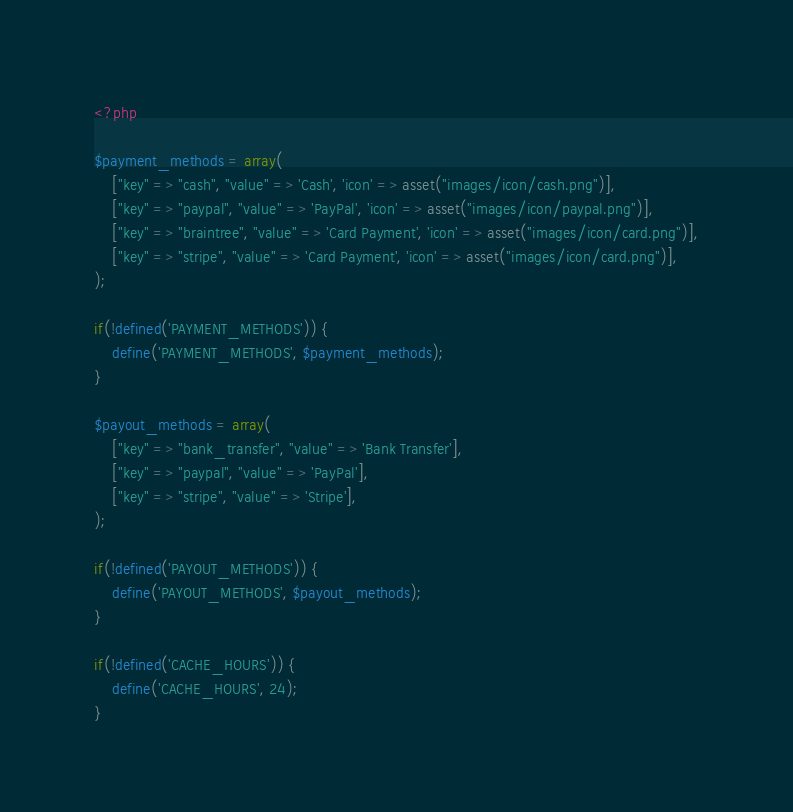<code> <loc_0><loc_0><loc_500><loc_500><_PHP_><?php

$payment_methods = array(
	["key" => "cash", "value" => 'Cash', 'icon' => asset("images/icon/cash.png")],
	["key" => "paypal", "value" => 'PayPal', 'icon' => asset("images/icon/paypal.png")],
	["key" => "braintree", "value" => 'Card Payment', 'icon' => asset("images/icon/card.png")],
	["key" => "stripe", "value" => 'Card Payment', 'icon' => asset("images/icon/card.png")],
);

if(!defined('PAYMENT_METHODS')) {
	define('PAYMENT_METHODS', $payment_methods);	
}

$payout_methods = array(
	["key" => "bank_transfer", "value" => 'Bank Transfer'],
	["key" => "paypal", "value" => 'PayPal'],
	["key" => "stripe", "value" => 'Stripe'],
);

if(!defined('PAYOUT_METHODS')) {
	define('PAYOUT_METHODS', $payout_methods);	
}

if(!defined('CACHE_HOURS')) {
	define('CACHE_HOURS', 24);	
}</code> 